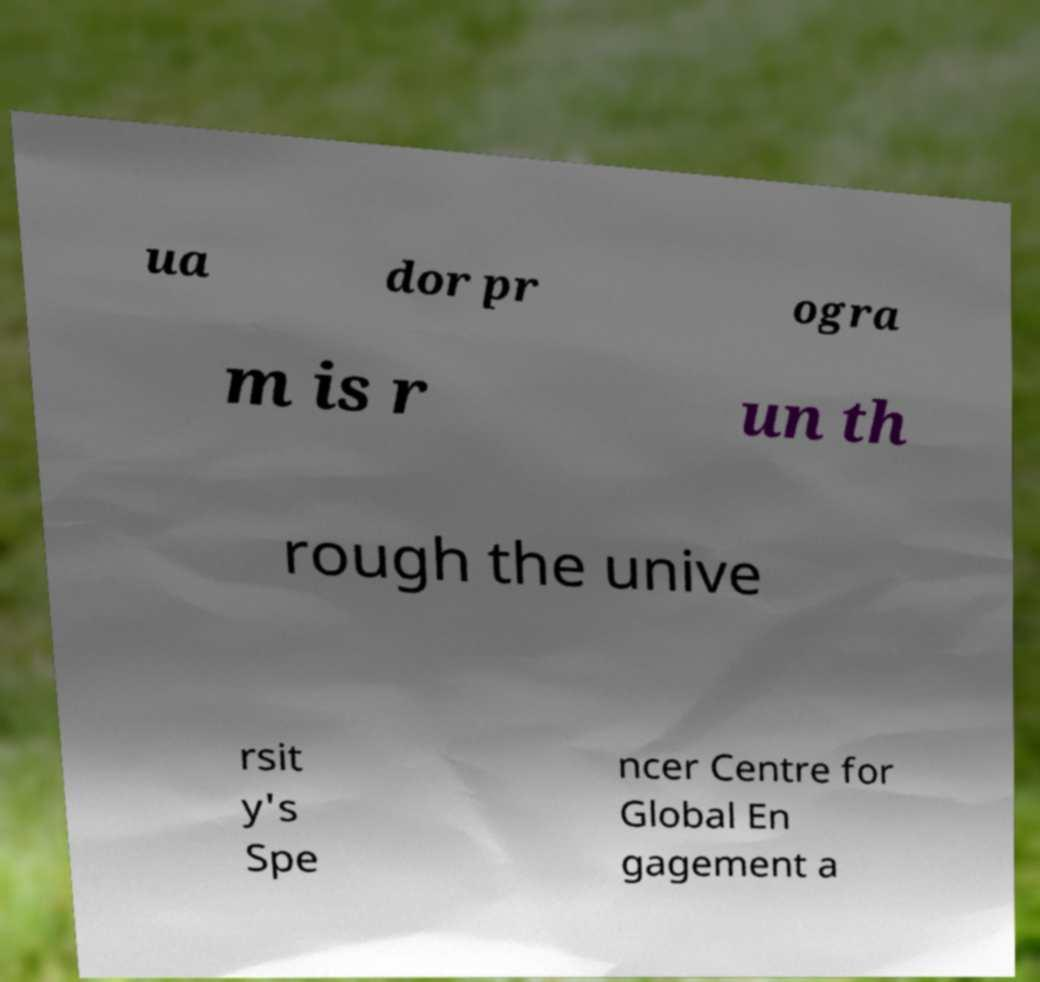Please identify and transcribe the text found in this image. ua dor pr ogra m is r un th rough the unive rsit y's Spe ncer Centre for Global En gagement a 